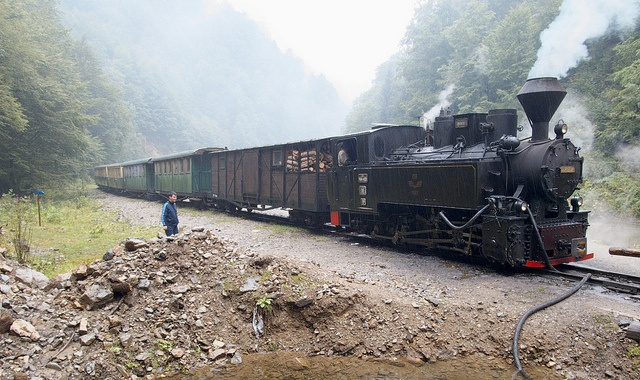Describe the objects in this image and their specific colors. I can see train in darkgray, black, and gray tones, people in darkgray, navy, gray, and darkblue tones, and people in darkgray, black, and gray tones in this image. 